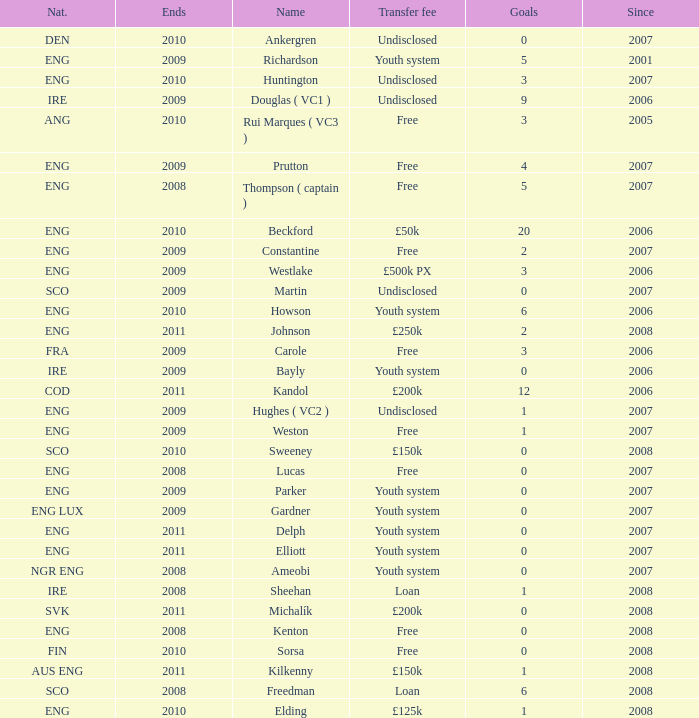Name the average ends for weston 2009.0. 